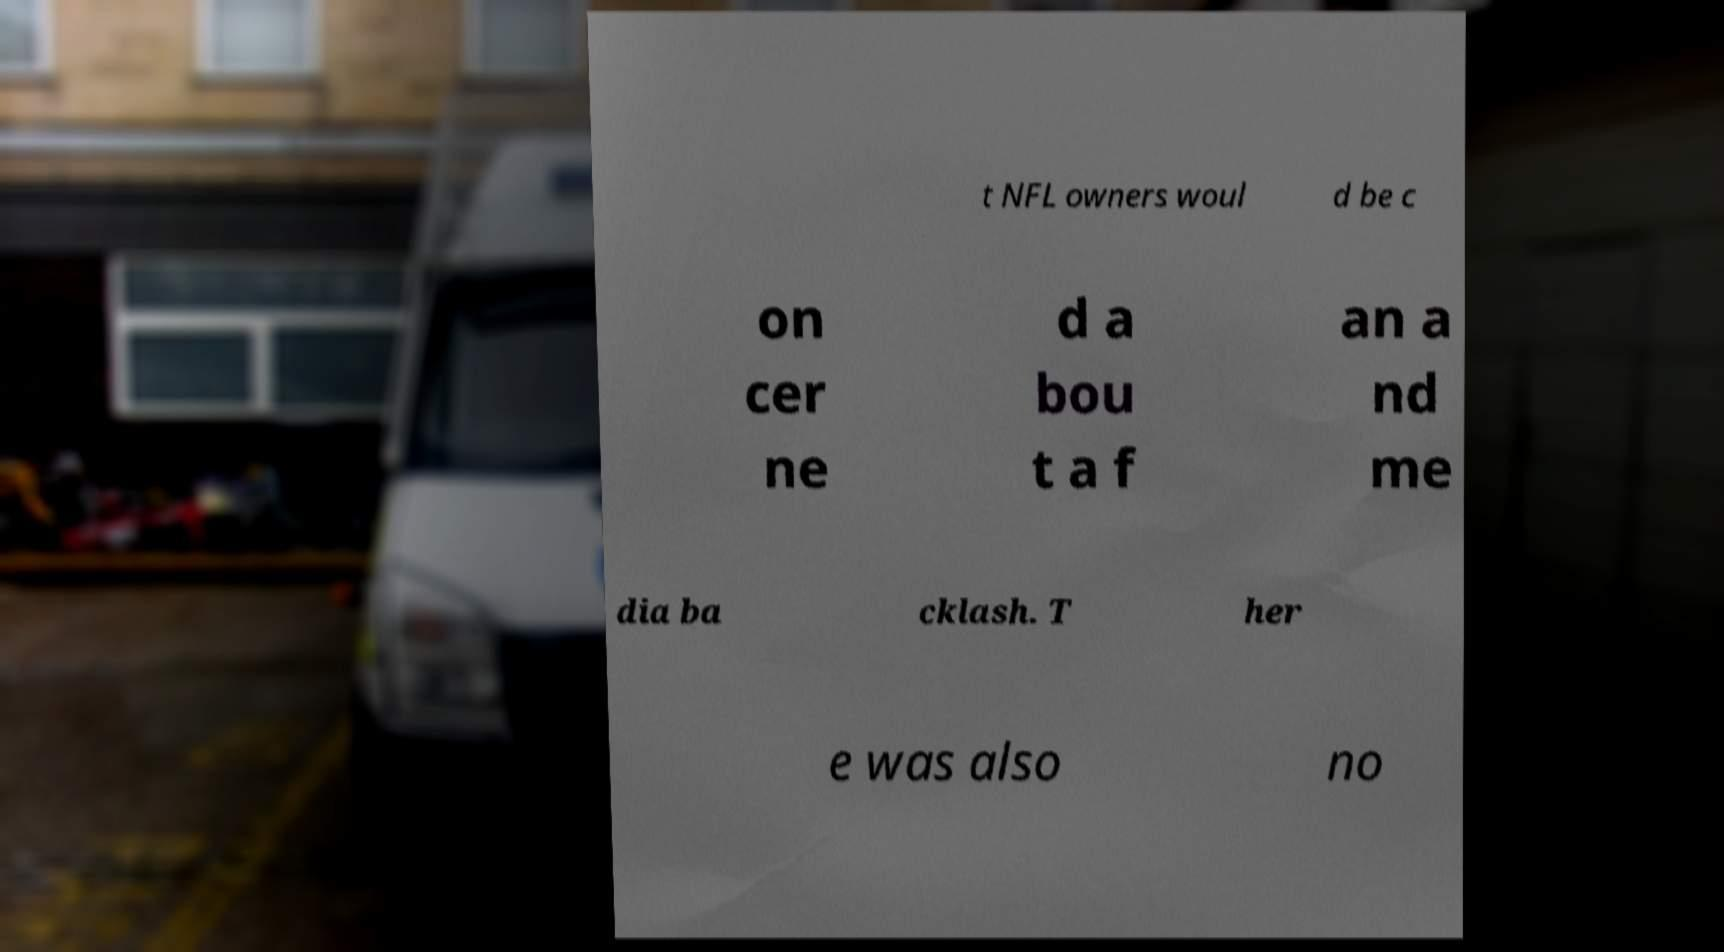I need the written content from this picture converted into text. Can you do that? t NFL owners woul d be c on cer ne d a bou t a f an a nd me dia ba cklash. T her e was also no 